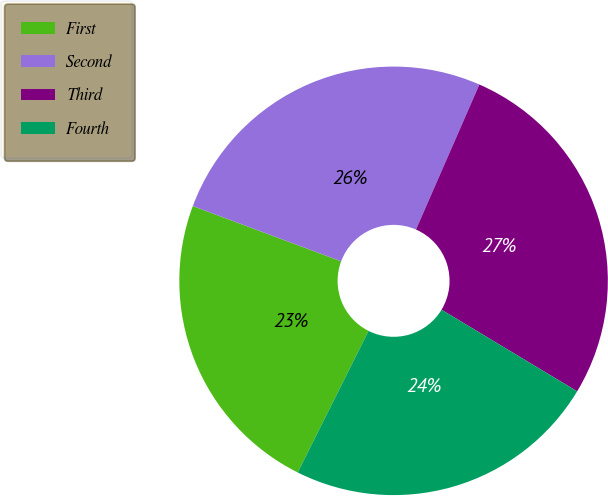Convert chart to OTSL. <chart><loc_0><loc_0><loc_500><loc_500><pie_chart><fcel>First<fcel>Second<fcel>Third<fcel>Fourth<nl><fcel>23.29%<fcel>25.88%<fcel>27.07%<fcel>23.76%<nl></chart> 